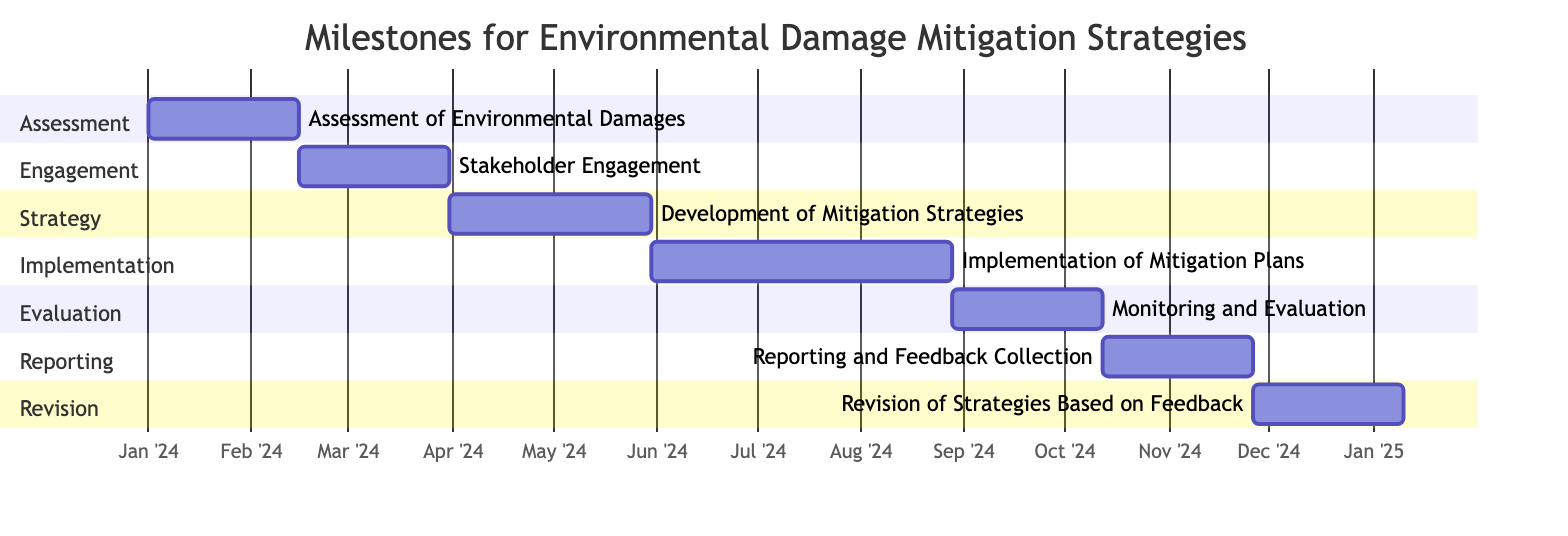What is the duration of the "Stakeholder Engagement" task? The "Stakeholder Engagement" task is listed with a duration of 45 days, as indicated in the provided data and also reflected in the diagram.
Answer: 45 days What is the start date for "Monitoring and Evaluation"? The "Monitoring and Evaluation" task starts immediately after the "Implementation of Mitigation Plans," which ends on September 1, 2024. Therefore, it starts on September 2, 2024.
Answer: September 2, 2024 How many days are allocated for the "Development of Mitigation Strategies"? The diagram shows that the "Development of Mitigation Strategies" task has a specified duration of 60 days. This is based on the data provided.
Answer: 60 days What is the end date for the "Implementation of Mitigation Plans"? The "Implementation of Mitigation Plans" task starts on June 2, 2024, and has a duration of 90 days. Calculating from this start date, the end date will be September 1, 2024.
Answer: September 1, 2024 Which task follows "Reporting and Feedback Collection"? According to the diagram, the "Revision of Strategies Based on Feedback" task follows the "Reporting and Feedback Collection," as it comes after that section in the timeline.
Answer: Revision of Strategies Based on Feedback How many total task milestones are outlined in this Gantt Chart? The chart outlines a total of seven tasks, which can be counted from the separate sections in the diagram.
Answer: Seven What is the relationship between "Assessment of Environmental Damages" and "Development of Mitigation Strategies"? The "Development of Mitigation Strategies" task is scheduled to begin after the completion of the "Stakeholder Engagement," which follows the "Assessment of Environmental Damages." Therefore, there is a sequential relationship, indicating the latter task follows the former through the intermediate task.
Answer: Sequential relationship What is the total duration of tasks in the Gantt Chart? To find the total, we add the durations of each task: 45 + 45 + 60 + 90 + 45 + 45 + 45 = 375 days.
Answer: 375 days 